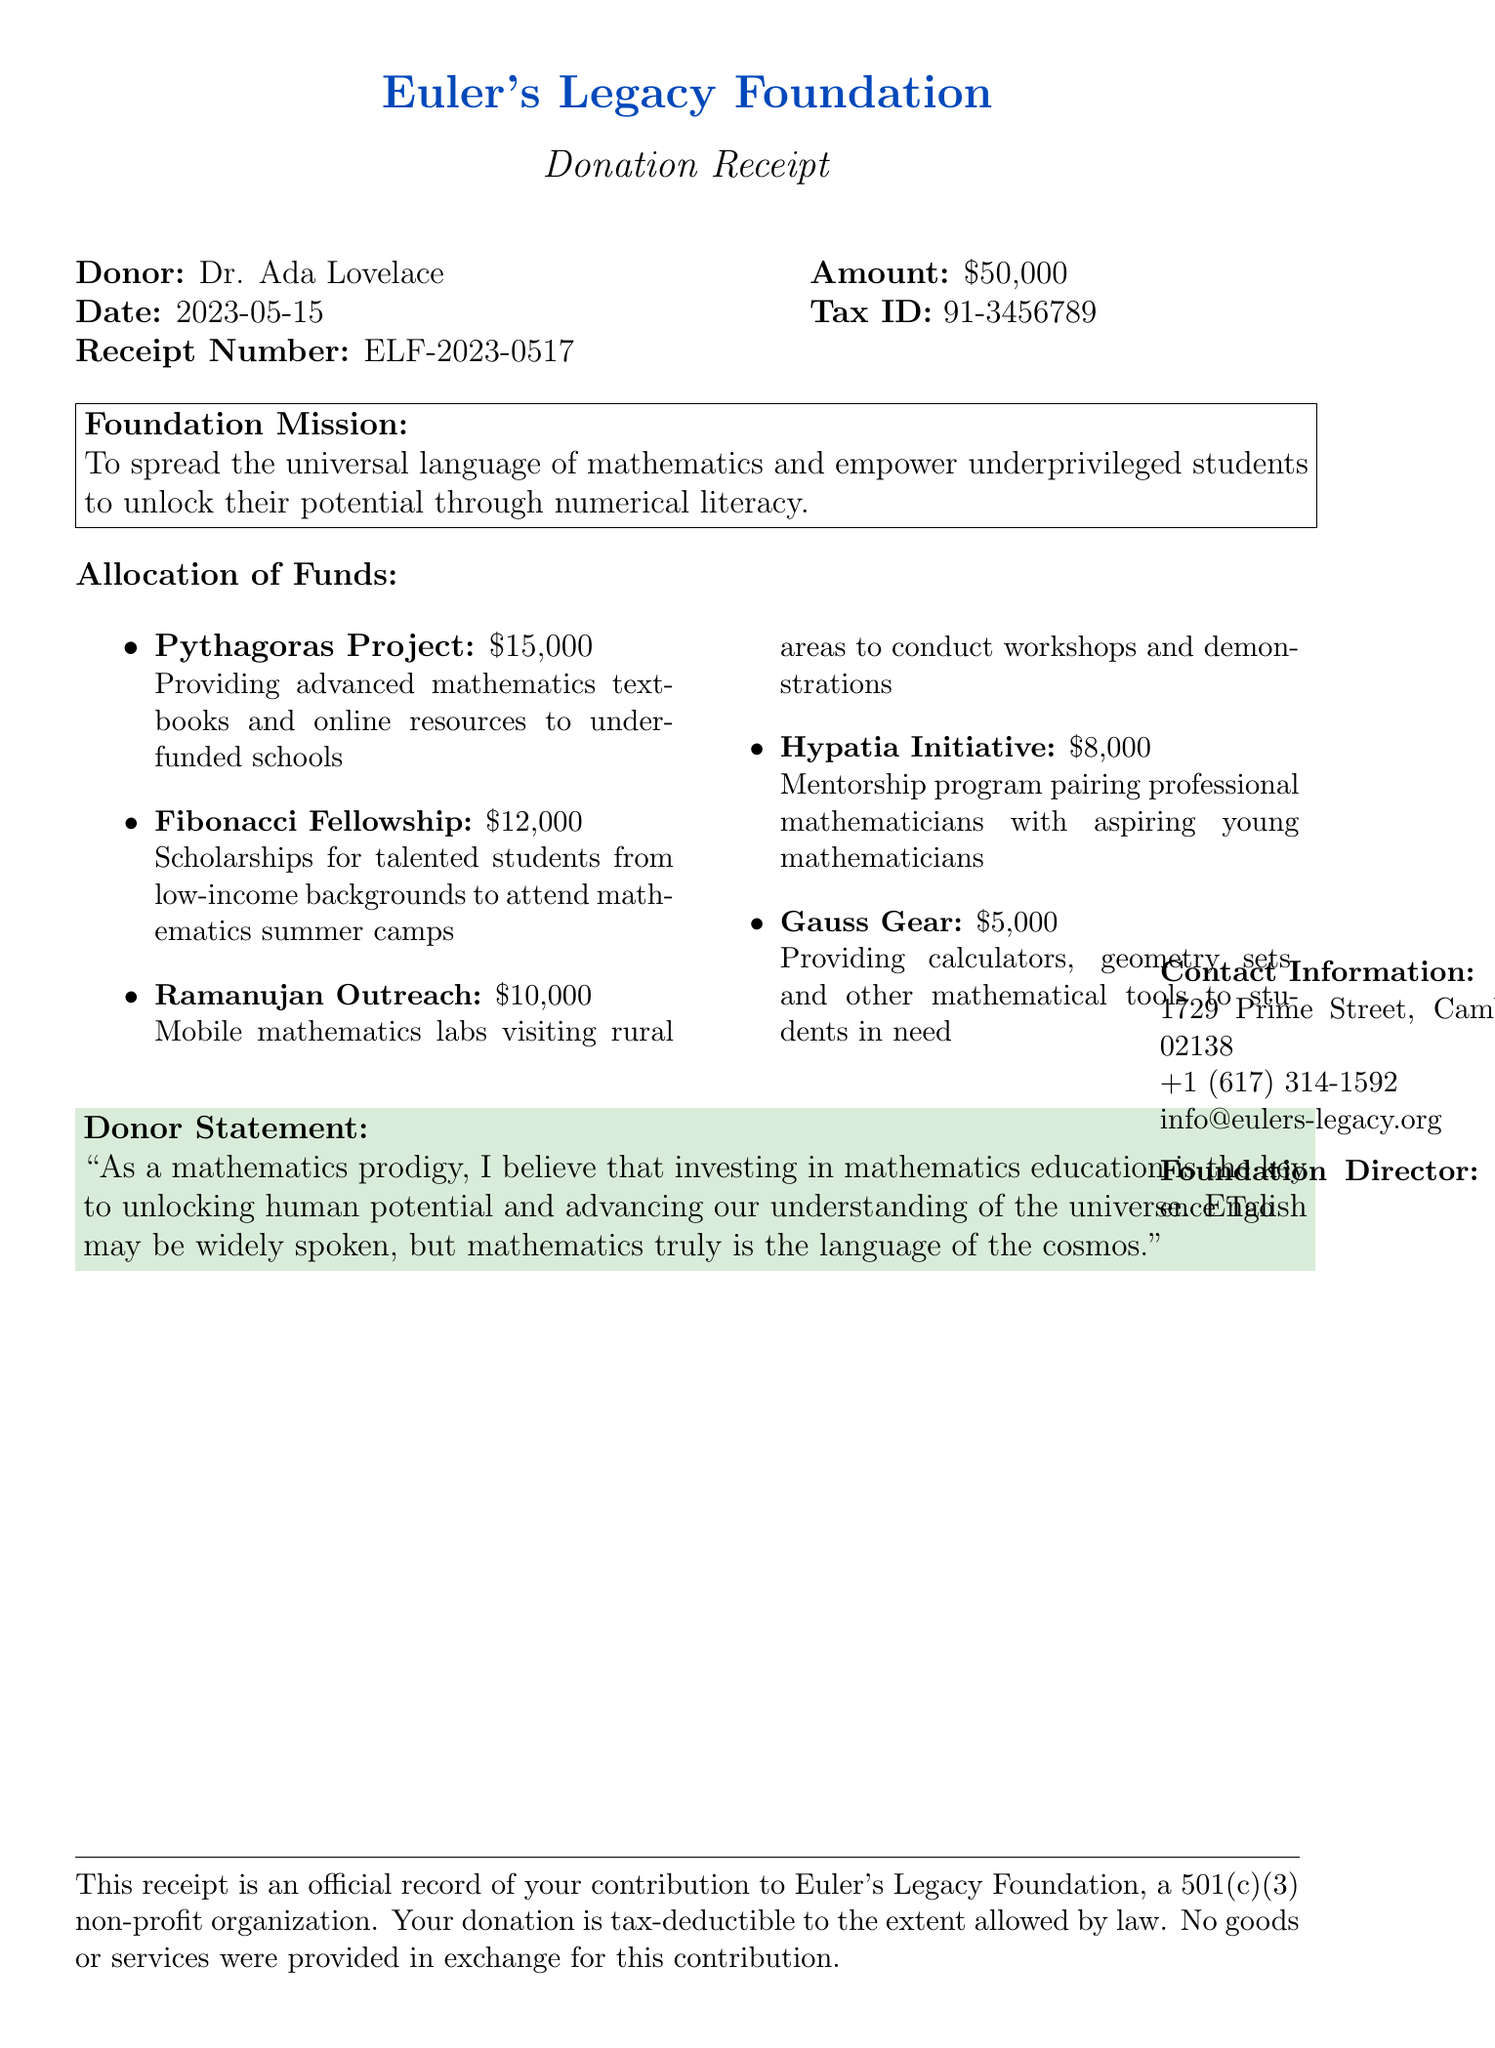What is the name of the foundation? The foundation's name is mentioned at the top of the document as Euler's Legacy Foundation.
Answer: Euler's Legacy Foundation Who is the donor of the contribution? The document specifies that the donor is Dr. Ada Lovelace.
Answer: Dr. Ada Lovelace What is the total amount donated? The total donation amount is clearly stated in the document as $50,000.
Answer: $50,000 What is the allocation for the Pythagoras Project? The document lists the allocation for the Pythagoras Project as $15,000.
Answer: $15,000 What is the foundation's mission? The foundation's mission is presented in a highlighted box as spreading the universal language of mathematics.
Answer: To spread the universal language of mathematics and empower underprivileged students to unlock their potential through numerical literacy How much funding is allocated for the Ramanujan Outreach? The document states that the allocation for the Ramanujan Outreach program is $10,000.
Answer: $10,000 What is the total allocation received by the Hypatia Initiative? The total allocation for the Hypatia Initiative is listed as $8,000 in the document.
Answer: $8,000 What is the receipt number? The receipt number can be found in the document as ELF-2023-0517.
Answer: ELF-2023-0517 Who is the director of the foundation? The document mentions that the foundation director is Prof. Terence Tao.
Answer: Prof. Terence Tao 